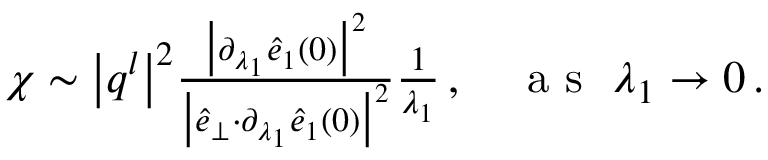Convert formula to latex. <formula><loc_0><loc_0><loc_500><loc_500>\begin{array} { r } { \chi \sim \left | q ^ { l } \right | ^ { 2 } \frac { \left | \partial _ { \lambda _ { 1 } } \hat { e } _ { 1 } ( 0 ) \right | ^ { 2 } } { \left | \hat { e } _ { \perp } { \cdot } \partial _ { \lambda _ { 1 } } \hat { e } _ { 1 } ( 0 ) \right | ^ { 2 } } \frac { 1 } { \lambda _ { 1 } } \, , a s \lambda _ { 1 } \rightarrow 0 \, . } \end{array}</formula> 